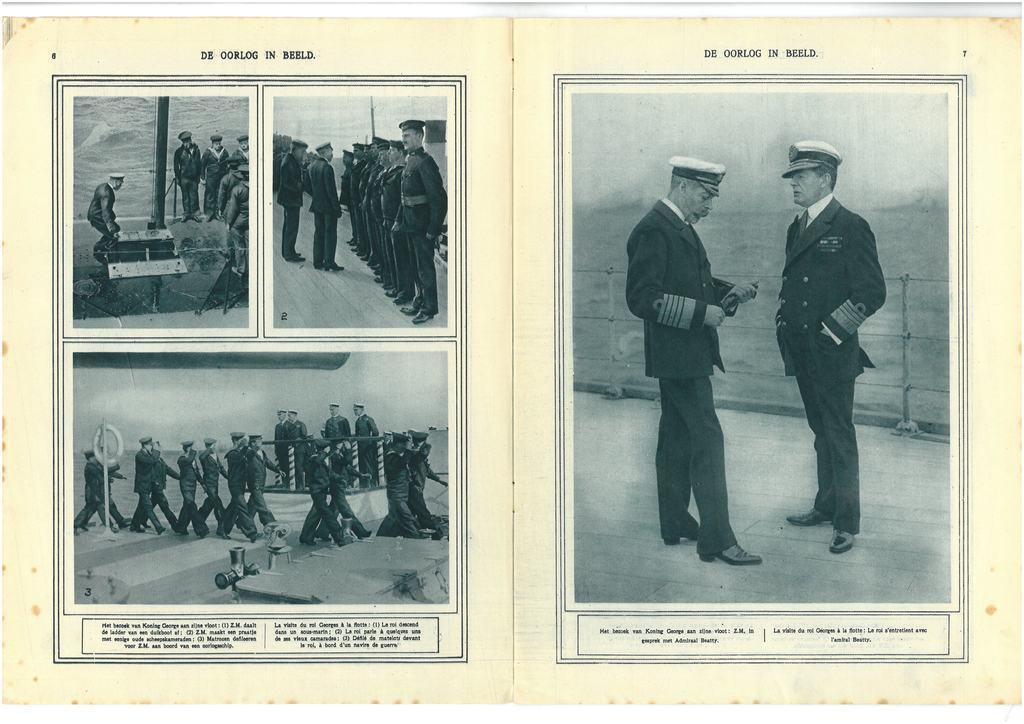What type of images are in the picture? The image contains black and white images of people. What are the people in the images wearing? The people in the images are wearing uniforms. What else can be seen in the images besides the people? There are objects present in the images. How many crates are visible in the image? There are no crates present in the image; it contains black and white images of people wearing uniforms. What type of flower can be seen in the image? There are no flowers present in the image, as it features black and white images of people wearing uniforms. 